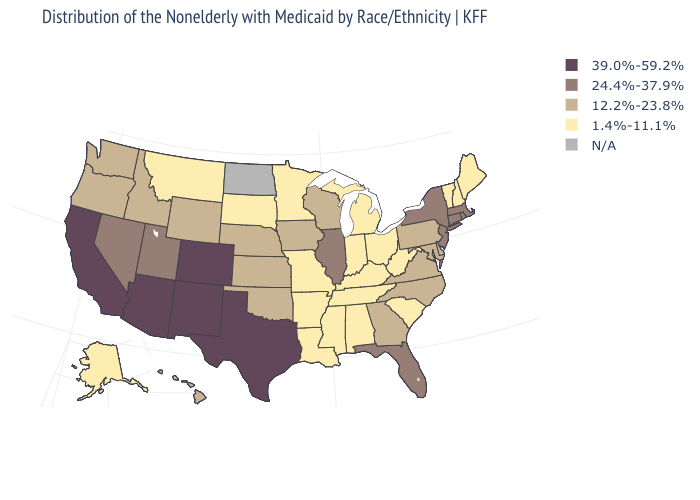Is the legend a continuous bar?
Write a very short answer. No. Name the states that have a value in the range 24.4%-37.9%?
Concise answer only. Connecticut, Florida, Illinois, Massachusetts, Nevada, New Jersey, New York, Rhode Island, Utah. Name the states that have a value in the range 12.2%-23.8%?
Answer briefly. Delaware, Georgia, Hawaii, Idaho, Iowa, Kansas, Maryland, Nebraska, North Carolina, Oklahoma, Oregon, Pennsylvania, Virginia, Washington, Wisconsin, Wyoming. What is the value of West Virginia?
Answer briefly. 1.4%-11.1%. Does the first symbol in the legend represent the smallest category?
Be succinct. No. What is the lowest value in the South?
Quick response, please. 1.4%-11.1%. Is the legend a continuous bar?
Keep it brief. No. What is the value of Maine?
Keep it brief. 1.4%-11.1%. What is the lowest value in the MidWest?
Be succinct. 1.4%-11.1%. Does the map have missing data?
Quick response, please. Yes. What is the highest value in the USA?
Keep it brief. 39.0%-59.2%. Among the states that border New York , which have the highest value?
Write a very short answer. Connecticut, Massachusetts, New Jersey. Name the states that have a value in the range N/A?
Answer briefly. North Dakota. 